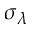<formula> <loc_0><loc_0><loc_500><loc_500>\sigma _ { \lambda }</formula> 